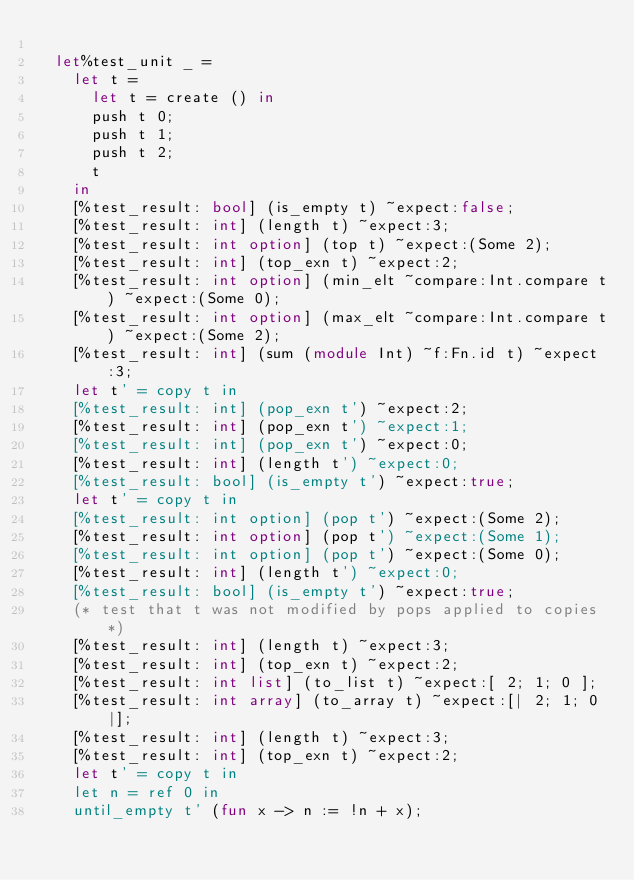Convert code to text. <code><loc_0><loc_0><loc_500><loc_500><_OCaml_>
  let%test_unit _ =
    let t =
      let t = create () in
      push t 0;
      push t 1;
      push t 2;
      t
    in
    [%test_result: bool] (is_empty t) ~expect:false;
    [%test_result: int] (length t) ~expect:3;
    [%test_result: int option] (top t) ~expect:(Some 2);
    [%test_result: int] (top_exn t) ~expect:2;
    [%test_result: int option] (min_elt ~compare:Int.compare t) ~expect:(Some 0);
    [%test_result: int option] (max_elt ~compare:Int.compare t) ~expect:(Some 2);
    [%test_result: int] (sum (module Int) ~f:Fn.id t) ~expect:3;
    let t' = copy t in
    [%test_result: int] (pop_exn t') ~expect:2;
    [%test_result: int] (pop_exn t') ~expect:1;
    [%test_result: int] (pop_exn t') ~expect:0;
    [%test_result: int] (length t') ~expect:0;
    [%test_result: bool] (is_empty t') ~expect:true;
    let t' = copy t in
    [%test_result: int option] (pop t') ~expect:(Some 2);
    [%test_result: int option] (pop t') ~expect:(Some 1);
    [%test_result: int option] (pop t') ~expect:(Some 0);
    [%test_result: int] (length t') ~expect:0;
    [%test_result: bool] (is_empty t') ~expect:true;
    (* test that t was not modified by pops applied to copies *)
    [%test_result: int] (length t) ~expect:3;
    [%test_result: int] (top_exn t) ~expect:2;
    [%test_result: int list] (to_list t) ~expect:[ 2; 1; 0 ];
    [%test_result: int array] (to_array t) ~expect:[| 2; 1; 0 |];
    [%test_result: int] (length t) ~expect:3;
    [%test_result: int] (top_exn t) ~expect:2;
    let t' = copy t in
    let n = ref 0 in
    until_empty t' (fun x -> n := !n + x);</code> 